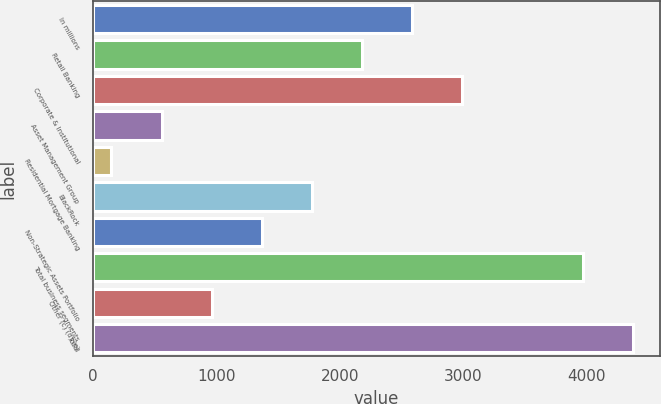Convert chart. <chart><loc_0><loc_0><loc_500><loc_500><bar_chart><fcel>In millions<fcel>Retail Banking<fcel>Corporate & Institutional<fcel>Asset Management Group<fcel>Residential Mortgage Banking<fcel>BlackRock<fcel>Non-Strategic Assets Portfolio<fcel>Total business segments<fcel>Other (c) (d) (e)<fcel>Total<nl><fcel>2586.4<fcel>2180<fcel>2992.8<fcel>554.4<fcel>148<fcel>1773.6<fcel>1367.2<fcel>3972<fcel>960.8<fcel>4378.4<nl></chart> 